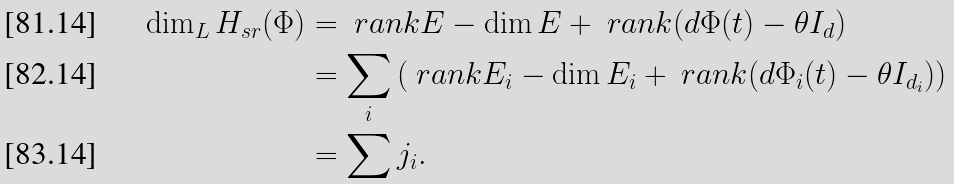<formula> <loc_0><loc_0><loc_500><loc_500>\dim _ { L } H _ { s r } ( \Phi ) & = \ r a n k E - \dim E + \ r a n k ( d \Phi ( t ) - \theta I _ { d } ) \\ & = \sum _ { i } \left ( \ r a n k E _ { i } - \dim E _ { i } + \ r a n k ( d \Phi _ { i } ( t ) - \theta I _ { d _ { i } } ) \right ) \\ & = \sum j _ { i } .</formula> 